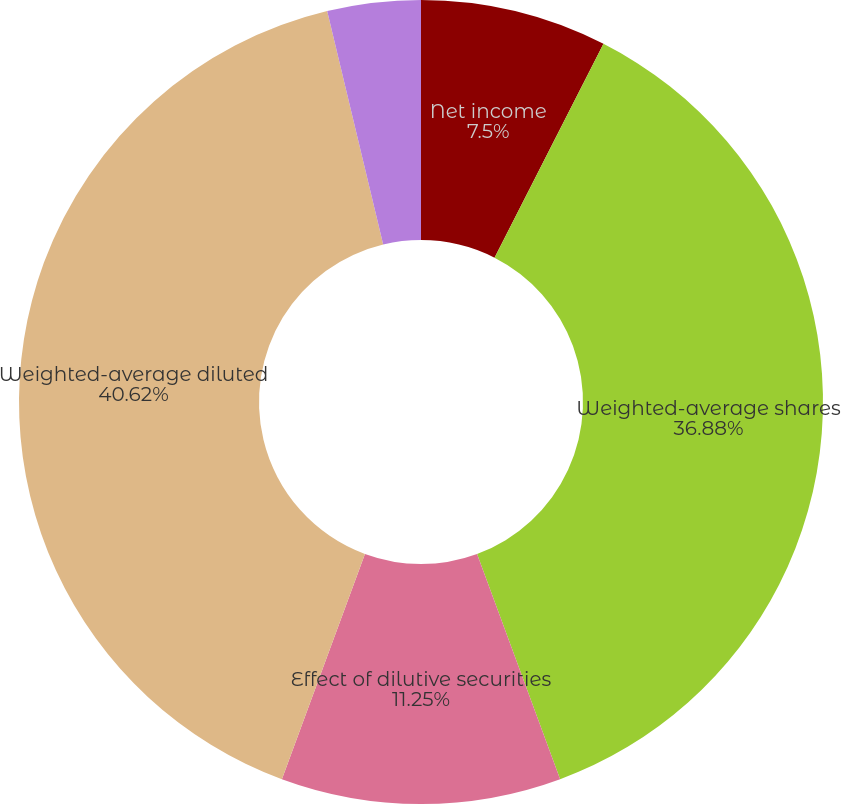Convert chart to OTSL. <chart><loc_0><loc_0><loc_500><loc_500><pie_chart><fcel>Net income<fcel>Weighted-average shares<fcel>Effect of dilutive securities<fcel>Weighted-average diluted<fcel>Basic earnings per common<fcel>Diluted earnings per common<nl><fcel>7.5%<fcel>36.88%<fcel>11.25%<fcel>40.63%<fcel>3.75%<fcel>0.0%<nl></chart> 